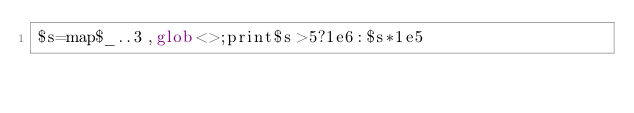Convert code to text. <code><loc_0><loc_0><loc_500><loc_500><_Perl_>$s=map$_..3,glob<>;print$s>5?1e6:$s*1e5</code> 